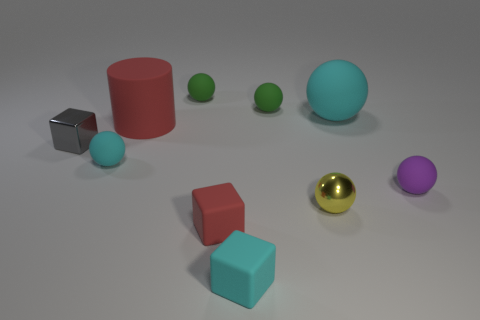Subtract 3 balls. How many balls are left? 3 Subtract all cyan balls. How many balls are left? 4 Subtract all tiny purple rubber spheres. How many spheres are left? 5 Subtract all red balls. Subtract all purple cylinders. How many balls are left? 6 Subtract all balls. How many objects are left? 4 Subtract all purple rubber spheres. Subtract all red matte cubes. How many objects are left? 8 Add 8 big spheres. How many big spheres are left? 9 Add 10 brown shiny cylinders. How many brown shiny cylinders exist? 10 Subtract 0 yellow cubes. How many objects are left? 10 